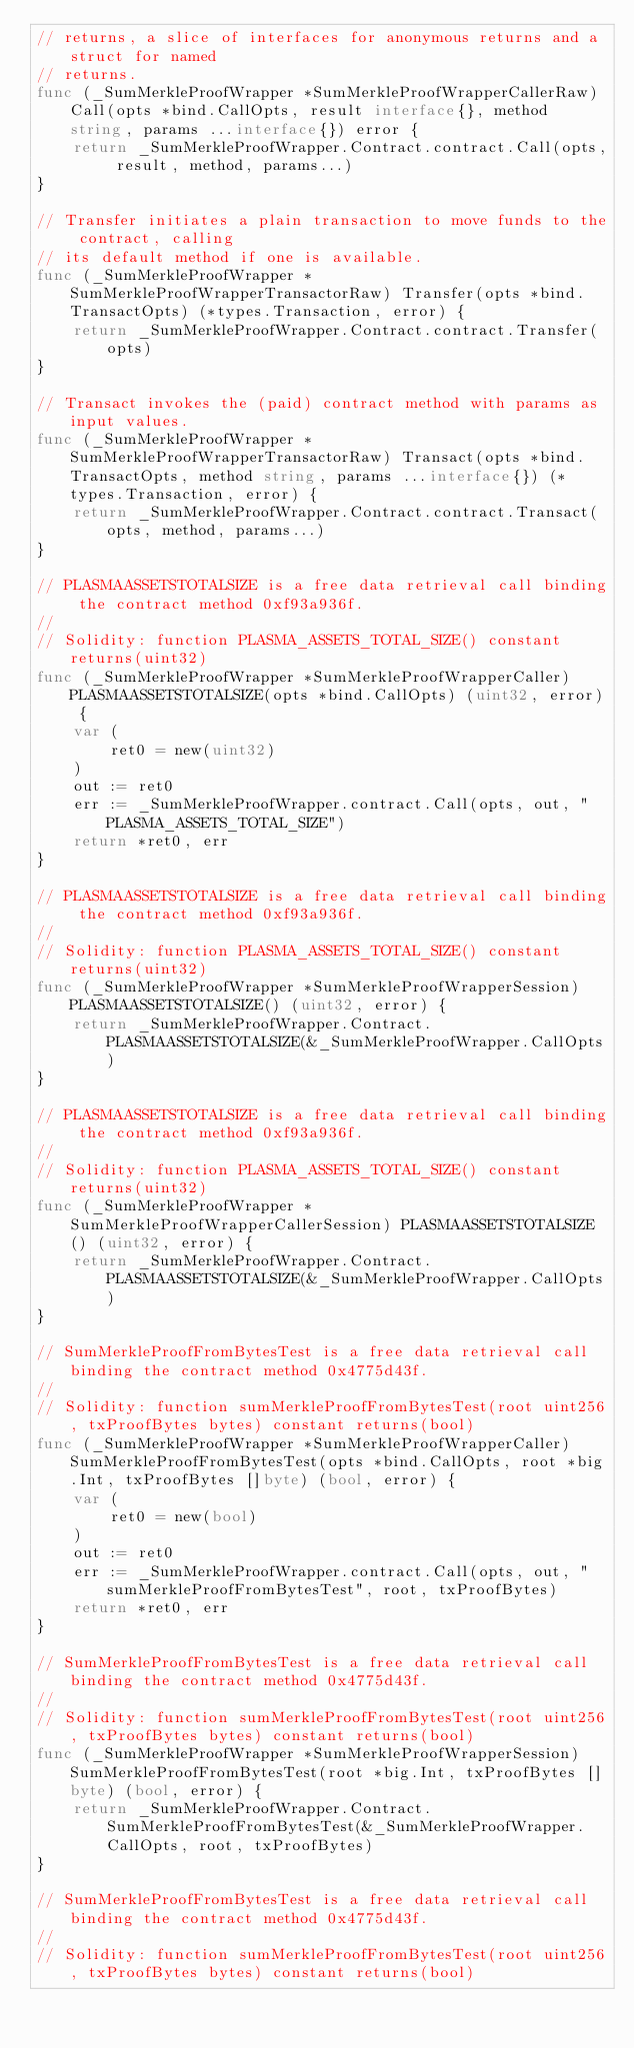Convert code to text. <code><loc_0><loc_0><loc_500><loc_500><_Go_>// returns, a slice of interfaces for anonymous returns and a struct for named
// returns.
func (_SumMerkleProofWrapper *SumMerkleProofWrapperCallerRaw) Call(opts *bind.CallOpts, result interface{}, method string, params ...interface{}) error {
	return _SumMerkleProofWrapper.Contract.contract.Call(opts, result, method, params...)
}

// Transfer initiates a plain transaction to move funds to the contract, calling
// its default method if one is available.
func (_SumMerkleProofWrapper *SumMerkleProofWrapperTransactorRaw) Transfer(opts *bind.TransactOpts) (*types.Transaction, error) {
	return _SumMerkleProofWrapper.Contract.contract.Transfer(opts)
}

// Transact invokes the (paid) contract method with params as input values.
func (_SumMerkleProofWrapper *SumMerkleProofWrapperTransactorRaw) Transact(opts *bind.TransactOpts, method string, params ...interface{}) (*types.Transaction, error) {
	return _SumMerkleProofWrapper.Contract.contract.Transact(opts, method, params...)
}

// PLASMAASSETSTOTALSIZE is a free data retrieval call binding the contract method 0xf93a936f.
//
// Solidity: function PLASMA_ASSETS_TOTAL_SIZE() constant returns(uint32)
func (_SumMerkleProofWrapper *SumMerkleProofWrapperCaller) PLASMAASSETSTOTALSIZE(opts *bind.CallOpts) (uint32, error) {
	var (
		ret0 = new(uint32)
	)
	out := ret0
	err := _SumMerkleProofWrapper.contract.Call(opts, out, "PLASMA_ASSETS_TOTAL_SIZE")
	return *ret0, err
}

// PLASMAASSETSTOTALSIZE is a free data retrieval call binding the contract method 0xf93a936f.
//
// Solidity: function PLASMA_ASSETS_TOTAL_SIZE() constant returns(uint32)
func (_SumMerkleProofWrapper *SumMerkleProofWrapperSession) PLASMAASSETSTOTALSIZE() (uint32, error) {
	return _SumMerkleProofWrapper.Contract.PLASMAASSETSTOTALSIZE(&_SumMerkleProofWrapper.CallOpts)
}

// PLASMAASSETSTOTALSIZE is a free data retrieval call binding the contract method 0xf93a936f.
//
// Solidity: function PLASMA_ASSETS_TOTAL_SIZE() constant returns(uint32)
func (_SumMerkleProofWrapper *SumMerkleProofWrapperCallerSession) PLASMAASSETSTOTALSIZE() (uint32, error) {
	return _SumMerkleProofWrapper.Contract.PLASMAASSETSTOTALSIZE(&_SumMerkleProofWrapper.CallOpts)
}

// SumMerkleProofFromBytesTest is a free data retrieval call binding the contract method 0x4775d43f.
//
// Solidity: function sumMerkleProofFromBytesTest(root uint256, txProofBytes bytes) constant returns(bool)
func (_SumMerkleProofWrapper *SumMerkleProofWrapperCaller) SumMerkleProofFromBytesTest(opts *bind.CallOpts, root *big.Int, txProofBytes []byte) (bool, error) {
	var (
		ret0 = new(bool)
	)
	out := ret0
	err := _SumMerkleProofWrapper.contract.Call(opts, out, "sumMerkleProofFromBytesTest", root, txProofBytes)
	return *ret0, err
}

// SumMerkleProofFromBytesTest is a free data retrieval call binding the contract method 0x4775d43f.
//
// Solidity: function sumMerkleProofFromBytesTest(root uint256, txProofBytes bytes) constant returns(bool)
func (_SumMerkleProofWrapper *SumMerkleProofWrapperSession) SumMerkleProofFromBytesTest(root *big.Int, txProofBytes []byte) (bool, error) {
	return _SumMerkleProofWrapper.Contract.SumMerkleProofFromBytesTest(&_SumMerkleProofWrapper.CallOpts, root, txProofBytes)
}

// SumMerkleProofFromBytesTest is a free data retrieval call binding the contract method 0x4775d43f.
//
// Solidity: function sumMerkleProofFromBytesTest(root uint256, txProofBytes bytes) constant returns(bool)</code> 